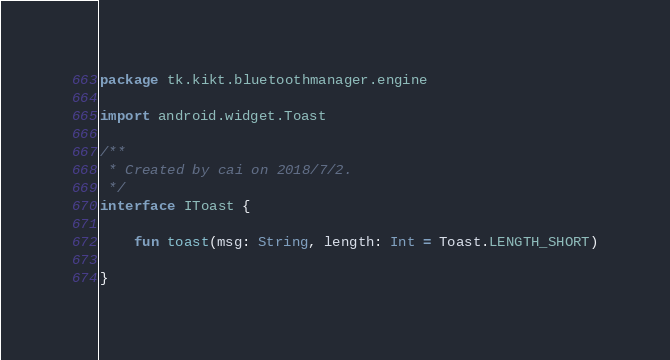Convert code to text. <code><loc_0><loc_0><loc_500><loc_500><_Kotlin_>package tk.kikt.bluetoothmanager.engine

import android.widget.Toast

/**
 * Created by cai on 2018/7/2.
 */
interface IToast {

    fun toast(msg: String, length: Int = Toast.LENGTH_SHORT)

}</code> 